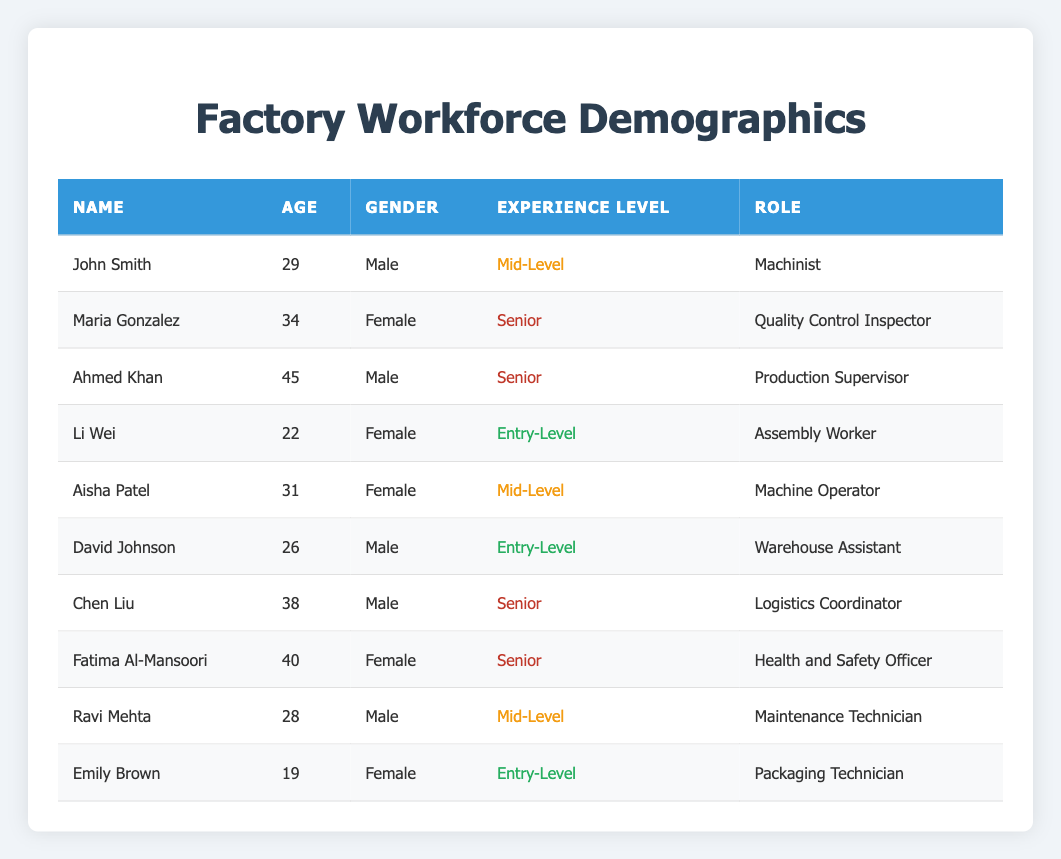What is the average age of the workforce? To find the average age, sum the ages of all workers: 29 + 34 + 45 + 22 + 31 + 26 + 38 + 40 + 28 + 19 =  372. Then, divide this sum by the number of workers, which is 10. So, 372 / 10 = 37.2.
Answer: 37.2 How many female employees are in the factory? By looking at the gender in the table, there are 5 females: Maria Gonzalez, Li Wei, Aisha Patel, Fatima Al-Mansoori, and Emily Brown.
Answer: 5 Which role has the highest representation in terms of experience level? There are 3 entry-level, 3 mid-level, and 4 senior employees. Since senior has the highest count among them, senior is the role with the most representatives.
Answer: Senior Is there anyone younger than 25 years old in the workforce? Yes, Li Wei is 22 and Emily Brown is 19, both of whom are younger than 25.
Answer: Yes How many male employees are at the senior experience level? The senior experience level includes Ahmed Khan, Chen Liu, and Fatima Al-Mansoori. There are 2 males: Ahmed Khan and Chen Liu.
Answer: 2 What percentage of the workforce is at the entry-level? There are 3 entry-level employees out of 10 total workers. To find the percentage, (3 / 10) * 100 = 30%.
Answer: 30% What is the age of the youngest employee? The youngest employee is Emily Brown, who is 19 years old.
Answer: 19 Which gender has more employees in the factory? By counting, there are 5 males (John Smith, Ahmed Khan, David Johnson, Chen Liu, Ravi Mehta) and 5 females (Maria Gonzalez, Li Wei, Aisha Patel, Fatima Al-Mansoori, Emily Brown). Both genders are equal in representation.
Answer: Equal How many employees are aged 30 and above? Counting the ages 30 and above: Maria Gonzalez (34), Ahmed Khan (45), Chen Liu (38), Fatima Al-Mansoori (40) gives us 4 workers aged 30 or above.
Answer: 4 Is there anyone with an experience level of mid-level and female? Yes, Aisha Patel is a mid-level female employee.
Answer: Yes 